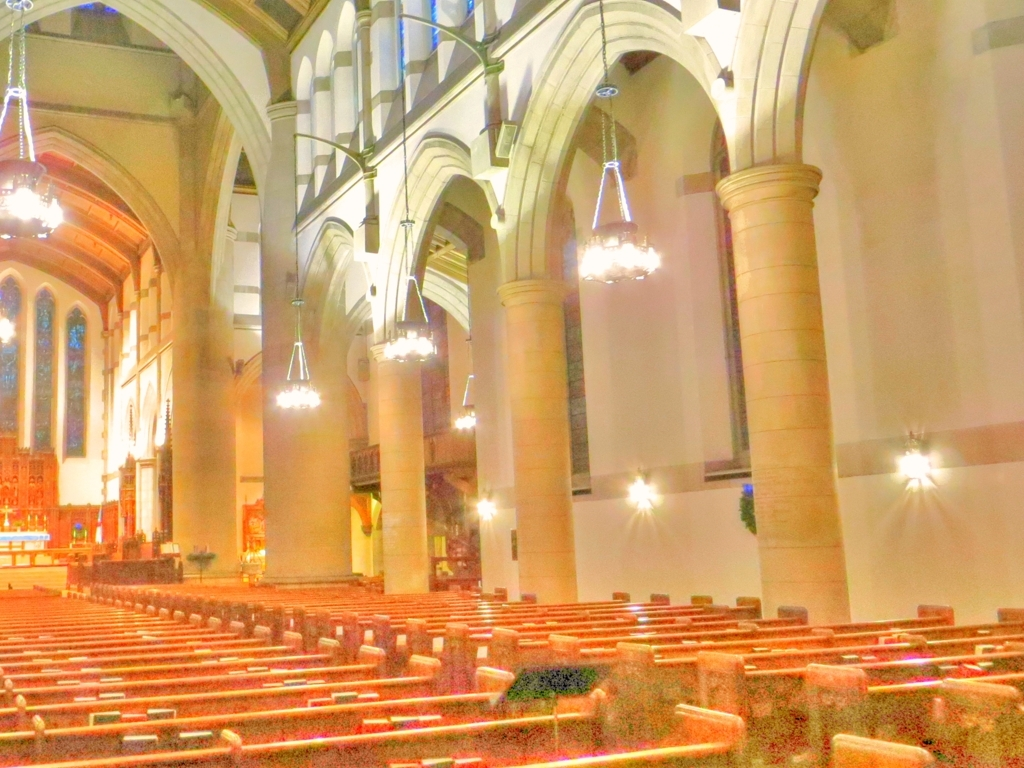What can you infer about the function of this building based on its interior? Based on the rows of pews, the altar at the front, and the overall design, the building appears to be a church or cathedral. Such a setup is indicative of a place intended for congregational worship, with a clear demarcation between the congregational seating area and the area designated for clergy and religious services. 